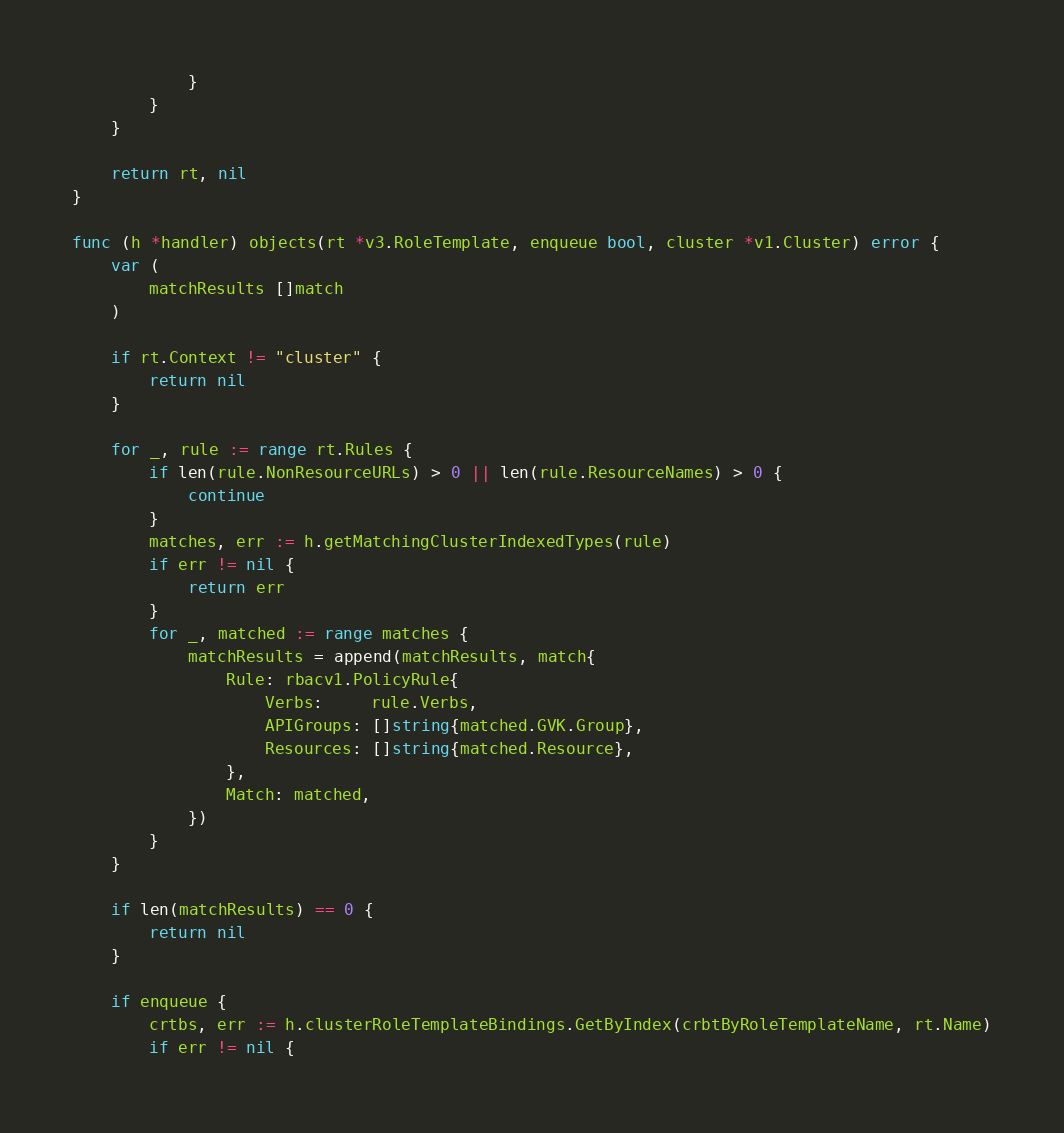<code> <loc_0><loc_0><loc_500><loc_500><_Go_>			}
		}
	}

	return rt, nil
}

func (h *handler) objects(rt *v3.RoleTemplate, enqueue bool, cluster *v1.Cluster) error {
	var (
		matchResults []match
	)

	if rt.Context != "cluster" {
		return nil
	}

	for _, rule := range rt.Rules {
		if len(rule.NonResourceURLs) > 0 || len(rule.ResourceNames) > 0 {
			continue
		}
		matches, err := h.getMatchingClusterIndexedTypes(rule)
		if err != nil {
			return err
		}
		for _, matched := range matches {
			matchResults = append(matchResults, match{
				Rule: rbacv1.PolicyRule{
					Verbs:     rule.Verbs,
					APIGroups: []string{matched.GVK.Group},
					Resources: []string{matched.Resource},
				},
				Match: matched,
			})
		}
	}

	if len(matchResults) == 0 {
		return nil
	}

	if enqueue {
		crtbs, err := h.clusterRoleTemplateBindings.GetByIndex(crbtByRoleTemplateName, rt.Name)
		if err != nil {</code> 